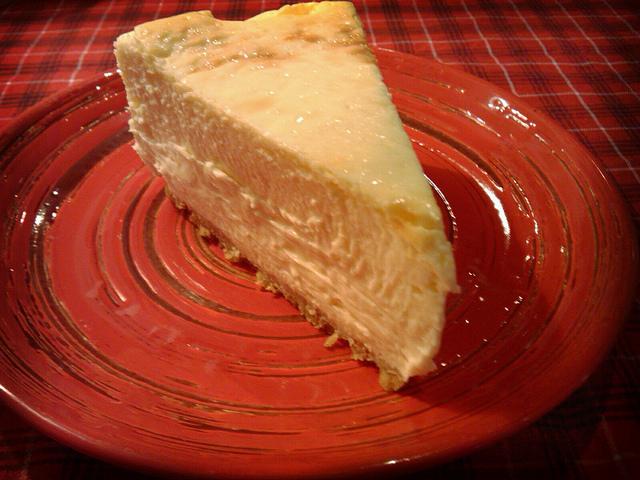What kind of cake is on the plate?
Quick response, please. Cheesecake. What is the color of the plate?
Answer briefly. Red. Does the plate match the tablecloth?
Quick response, please. Yes. 